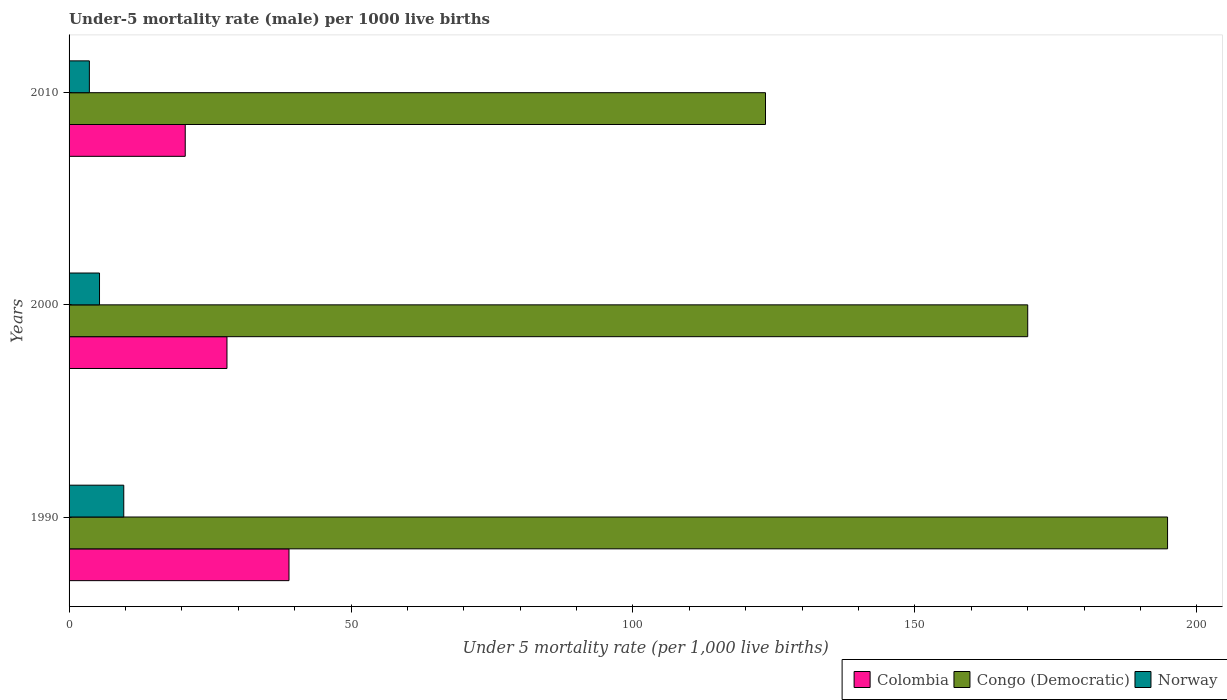How many different coloured bars are there?
Your response must be concise. 3. How many groups of bars are there?
Provide a short and direct response. 3. Are the number of bars per tick equal to the number of legend labels?
Offer a very short reply. Yes. Are the number of bars on each tick of the Y-axis equal?
Offer a very short reply. Yes. How many bars are there on the 2nd tick from the top?
Provide a short and direct response. 3. How many bars are there on the 2nd tick from the bottom?
Provide a short and direct response. 3. What is the label of the 3rd group of bars from the top?
Your response must be concise. 1990. In how many cases, is the number of bars for a given year not equal to the number of legend labels?
Offer a very short reply. 0. What is the under-five mortality rate in Congo (Democratic) in 2010?
Provide a short and direct response. 123.5. Across all years, what is the minimum under-five mortality rate in Colombia?
Make the answer very short. 20.6. In which year was the under-five mortality rate in Norway maximum?
Your response must be concise. 1990. What is the total under-five mortality rate in Congo (Democratic) in the graph?
Your answer should be very brief. 488.3. What is the difference between the under-five mortality rate in Congo (Democratic) in 1990 and the under-five mortality rate in Colombia in 2000?
Provide a succinct answer. 166.8. What is the average under-five mortality rate in Norway per year?
Offer a very short reply. 6.23. In the year 2000, what is the difference between the under-five mortality rate in Norway and under-five mortality rate in Colombia?
Your answer should be very brief. -22.6. What is the ratio of the under-five mortality rate in Congo (Democratic) in 1990 to that in 2010?
Keep it short and to the point. 1.58. Is the under-five mortality rate in Norway in 1990 less than that in 2010?
Make the answer very short. No. What is the difference between the highest and the second highest under-five mortality rate in Congo (Democratic)?
Ensure brevity in your answer.  24.8. What does the 2nd bar from the bottom in 1990 represents?
Make the answer very short. Congo (Democratic). Is it the case that in every year, the sum of the under-five mortality rate in Norway and under-five mortality rate in Congo (Democratic) is greater than the under-five mortality rate in Colombia?
Your answer should be compact. Yes. Are all the bars in the graph horizontal?
Your answer should be very brief. Yes. How many years are there in the graph?
Provide a succinct answer. 3. What is the difference between two consecutive major ticks on the X-axis?
Offer a very short reply. 50. Are the values on the major ticks of X-axis written in scientific E-notation?
Ensure brevity in your answer.  No. Does the graph contain grids?
Make the answer very short. No. Where does the legend appear in the graph?
Ensure brevity in your answer.  Bottom right. How many legend labels are there?
Offer a very short reply. 3. What is the title of the graph?
Ensure brevity in your answer.  Under-5 mortality rate (male) per 1000 live births. Does "Guinea" appear as one of the legend labels in the graph?
Provide a short and direct response. No. What is the label or title of the X-axis?
Provide a short and direct response. Under 5 mortality rate (per 1,0 live births). What is the Under 5 mortality rate (per 1,000 live births) of Colombia in 1990?
Your answer should be compact. 39. What is the Under 5 mortality rate (per 1,000 live births) of Congo (Democratic) in 1990?
Offer a very short reply. 194.8. What is the Under 5 mortality rate (per 1,000 live births) in Congo (Democratic) in 2000?
Keep it short and to the point. 170. What is the Under 5 mortality rate (per 1,000 live births) of Colombia in 2010?
Your answer should be compact. 20.6. What is the Under 5 mortality rate (per 1,000 live births) in Congo (Democratic) in 2010?
Provide a short and direct response. 123.5. What is the Under 5 mortality rate (per 1,000 live births) in Norway in 2010?
Make the answer very short. 3.6. Across all years, what is the maximum Under 5 mortality rate (per 1,000 live births) in Congo (Democratic)?
Make the answer very short. 194.8. Across all years, what is the maximum Under 5 mortality rate (per 1,000 live births) in Norway?
Offer a very short reply. 9.7. Across all years, what is the minimum Under 5 mortality rate (per 1,000 live births) in Colombia?
Your answer should be compact. 20.6. Across all years, what is the minimum Under 5 mortality rate (per 1,000 live births) of Congo (Democratic)?
Keep it short and to the point. 123.5. Across all years, what is the minimum Under 5 mortality rate (per 1,000 live births) in Norway?
Your response must be concise. 3.6. What is the total Under 5 mortality rate (per 1,000 live births) of Colombia in the graph?
Make the answer very short. 87.6. What is the total Under 5 mortality rate (per 1,000 live births) of Congo (Democratic) in the graph?
Your answer should be very brief. 488.3. What is the difference between the Under 5 mortality rate (per 1,000 live births) in Colombia in 1990 and that in 2000?
Your response must be concise. 11. What is the difference between the Under 5 mortality rate (per 1,000 live births) of Congo (Democratic) in 1990 and that in 2000?
Your response must be concise. 24.8. What is the difference between the Under 5 mortality rate (per 1,000 live births) of Norway in 1990 and that in 2000?
Offer a very short reply. 4.3. What is the difference between the Under 5 mortality rate (per 1,000 live births) of Colombia in 1990 and that in 2010?
Provide a short and direct response. 18.4. What is the difference between the Under 5 mortality rate (per 1,000 live births) in Congo (Democratic) in 1990 and that in 2010?
Your response must be concise. 71.3. What is the difference between the Under 5 mortality rate (per 1,000 live births) of Congo (Democratic) in 2000 and that in 2010?
Give a very brief answer. 46.5. What is the difference between the Under 5 mortality rate (per 1,000 live births) of Norway in 2000 and that in 2010?
Your answer should be very brief. 1.8. What is the difference between the Under 5 mortality rate (per 1,000 live births) of Colombia in 1990 and the Under 5 mortality rate (per 1,000 live births) of Congo (Democratic) in 2000?
Your answer should be very brief. -131. What is the difference between the Under 5 mortality rate (per 1,000 live births) of Colombia in 1990 and the Under 5 mortality rate (per 1,000 live births) of Norway in 2000?
Ensure brevity in your answer.  33.6. What is the difference between the Under 5 mortality rate (per 1,000 live births) of Congo (Democratic) in 1990 and the Under 5 mortality rate (per 1,000 live births) of Norway in 2000?
Ensure brevity in your answer.  189.4. What is the difference between the Under 5 mortality rate (per 1,000 live births) of Colombia in 1990 and the Under 5 mortality rate (per 1,000 live births) of Congo (Democratic) in 2010?
Provide a succinct answer. -84.5. What is the difference between the Under 5 mortality rate (per 1,000 live births) in Colombia in 1990 and the Under 5 mortality rate (per 1,000 live births) in Norway in 2010?
Give a very brief answer. 35.4. What is the difference between the Under 5 mortality rate (per 1,000 live births) of Congo (Democratic) in 1990 and the Under 5 mortality rate (per 1,000 live births) of Norway in 2010?
Your answer should be compact. 191.2. What is the difference between the Under 5 mortality rate (per 1,000 live births) in Colombia in 2000 and the Under 5 mortality rate (per 1,000 live births) in Congo (Democratic) in 2010?
Ensure brevity in your answer.  -95.5. What is the difference between the Under 5 mortality rate (per 1,000 live births) in Colombia in 2000 and the Under 5 mortality rate (per 1,000 live births) in Norway in 2010?
Offer a very short reply. 24.4. What is the difference between the Under 5 mortality rate (per 1,000 live births) of Congo (Democratic) in 2000 and the Under 5 mortality rate (per 1,000 live births) of Norway in 2010?
Keep it short and to the point. 166.4. What is the average Under 5 mortality rate (per 1,000 live births) in Colombia per year?
Offer a terse response. 29.2. What is the average Under 5 mortality rate (per 1,000 live births) in Congo (Democratic) per year?
Give a very brief answer. 162.77. What is the average Under 5 mortality rate (per 1,000 live births) in Norway per year?
Your answer should be compact. 6.23. In the year 1990, what is the difference between the Under 5 mortality rate (per 1,000 live births) in Colombia and Under 5 mortality rate (per 1,000 live births) in Congo (Democratic)?
Your answer should be compact. -155.8. In the year 1990, what is the difference between the Under 5 mortality rate (per 1,000 live births) in Colombia and Under 5 mortality rate (per 1,000 live births) in Norway?
Provide a short and direct response. 29.3. In the year 1990, what is the difference between the Under 5 mortality rate (per 1,000 live births) of Congo (Democratic) and Under 5 mortality rate (per 1,000 live births) of Norway?
Provide a succinct answer. 185.1. In the year 2000, what is the difference between the Under 5 mortality rate (per 1,000 live births) of Colombia and Under 5 mortality rate (per 1,000 live births) of Congo (Democratic)?
Your response must be concise. -142. In the year 2000, what is the difference between the Under 5 mortality rate (per 1,000 live births) in Colombia and Under 5 mortality rate (per 1,000 live births) in Norway?
Provide a succinct answer. 22.6. In the year 2000, what is the difference between the Under 5 mortality rate (per 1,000 live births) in Congo (Democratic) and Under 5 mortality rate (per 1,000 live births) in Norway?
Keep it short and to the point. 164.6. In the year 2010, what is the difference between the Under 5 mortality rate (per 1,000 live births) of Colombia and Under 5 mortality rate (per 1,000 live births) of Congo (Democratic)?
Offer a terse response. -102.9. In the year 2010, what is the difference between the Under 5 mortality rate (per 1,000 live births) of Colombia and Under 5 mortality rate (per 1,000 live births) of Norway?
Keep it short and to the point. 17. In the year 2010, what is the difference between the Under 5 mortality rate (per 1,000 live births) of Congo (Democratic) and Under 5 mortality rate (per 1,000 live births) of Norway?
Keep it short and to the point. 119.9. What is the ratio of the Under 5 mortality rate (per 1,000 live births) of Colombia in 1990 to that in 2000?
Offer a very short reply. 1.39. What is the ratio of the Under 5 mortality rate (per 1,000 live births) in Congo (Democratic) in 1990 to that in 2000?
Keep it short and to the point. 1.15. What is the ratio of the Under 5 mortality rate (per 1,000 live births) of Norway in 1990 to that in 2000?
Keep it short and to the point. 1.8. What is the ratio of the Under 5 mortality rate (per 1,000 live births) in Colombia in 1990 to that in 2010?
Offer a terse response. 1.89. What is the ratio of the Under 5 mortality rate (per 1,000 live births) of Congo (Democratic) in 1990 to that in 2010?
Give a very brief answer. 1.58. What is the ratio of the Under 5 mortality rate (per 1,000 live births) of Norway in 1990 to that in 2010?
Provide a succinct answer. 2.69. What is the ratio of the Under 5 mortality rate (per 1,000 live births) of Colombia in 2000 to that in 2010?
Provide a succinct answer. 1.36. What is the ratio of the Under 5 mortality rate (per 1,000 live births) of Congo (Democratic) in 2000 to that in 2010?
Give a very brief answer. 1.38. What is the difference between the highest and the second highest Under 5 mortality rate (per 1,000 live births) in Colombia?
Provide a succinct answer. 11. What is the difference between the highest and the second highest Under 5 mortality rate (per 1,000 live births) in Congo (Democratic)?
Provide a succinct answer. 24.8. What is the difference between the highest and the lowest Under 5 mortality rate (per 1,000 live births) of Congo (Democratic)?
Provide a short and direct response. 71.3. 